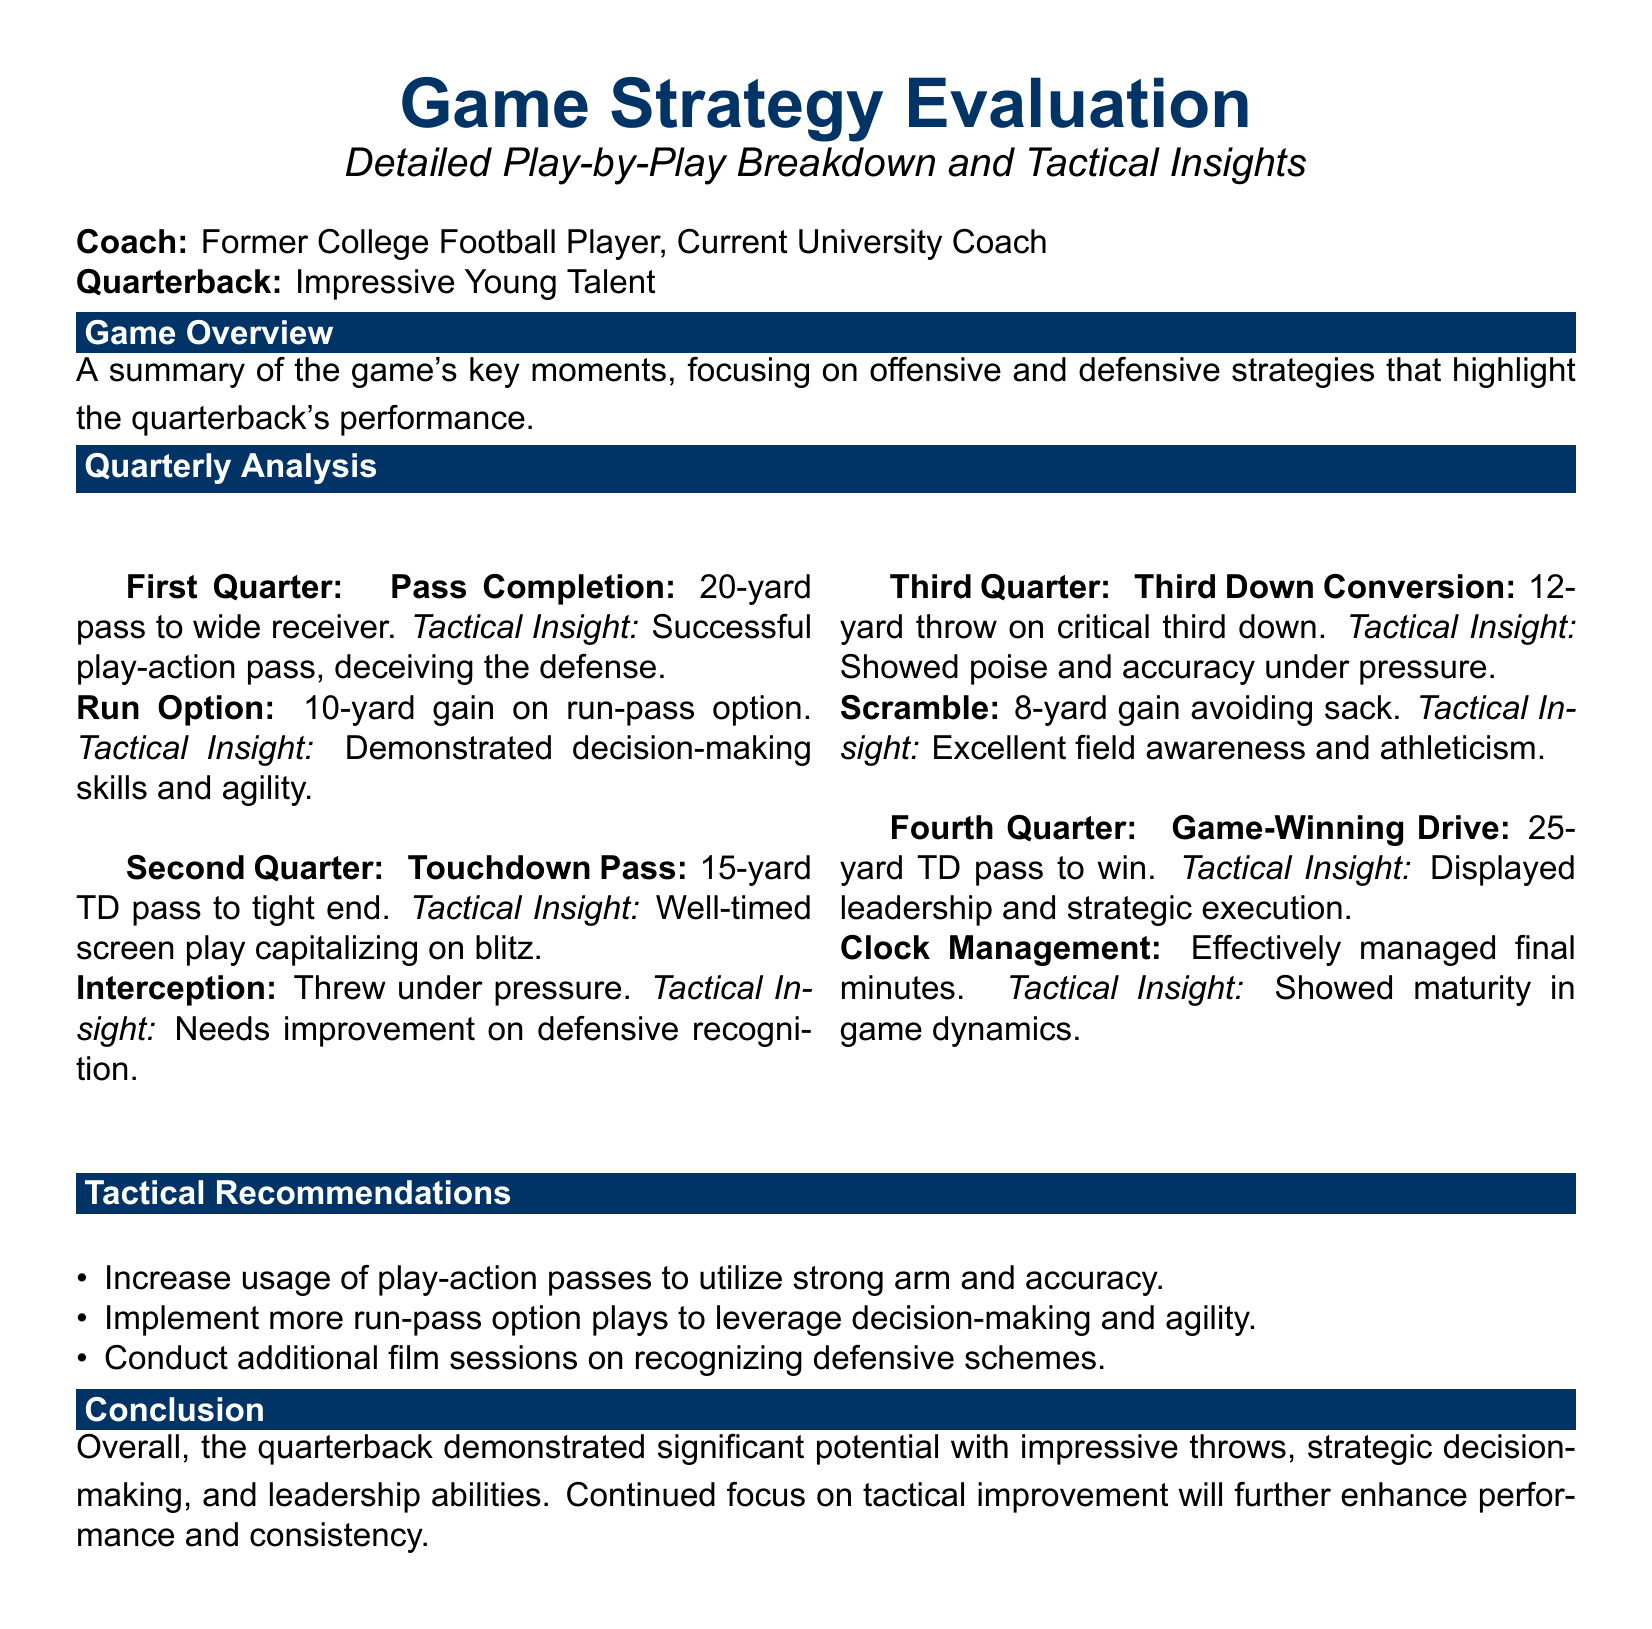What is the quarterback's name? The quarterback mentioned in the document is referred to as "Impressive Young Talent."
Answer: Impressive Young Talent How many touchdowns did the quarterback throw? The document indicates one touchdown pass in the second quarter and one in the fourth quarter, totaling two.
Answer: 2 What type of play was executed for the first 20-yard pass? The first 20-yard pass was a play-action pass that successfully deceived the defense.
Answer: Play-action pass Which quarter involved a critical third down conversion? The critical third down conversion occurred in the third quarter.
Answer: Third quarter What tactical recommendation involves increasing usage? The recommendation suggests increasing the usage of play-action passes to leverage the quarterback’s strong arm and accuracy.
Answer: Play-action passes What was the outcome of the game-winning drive play? The game-winning drive resulted in a 25-yard touchdown pass.
Answer: 25-yard touchdown pass During which quarter did the quarterback show poor defensive recognition? The poor defensive recognition occurred during the second quarter when an interception was thrown under pressure.
Answer: Second quarter What skills did the quarterback demonstrate during the run-pass option? The quarterback demonstrated decision-making skills and agility during the run-pass option.
Answer: Decision-making skills and agility How did the quarterback manage the final minutes of the game? The quarterback effectively managed the final minutes, demonstrating maturity in understanding game dynamics.
Answer: Effectively managed final minutes 